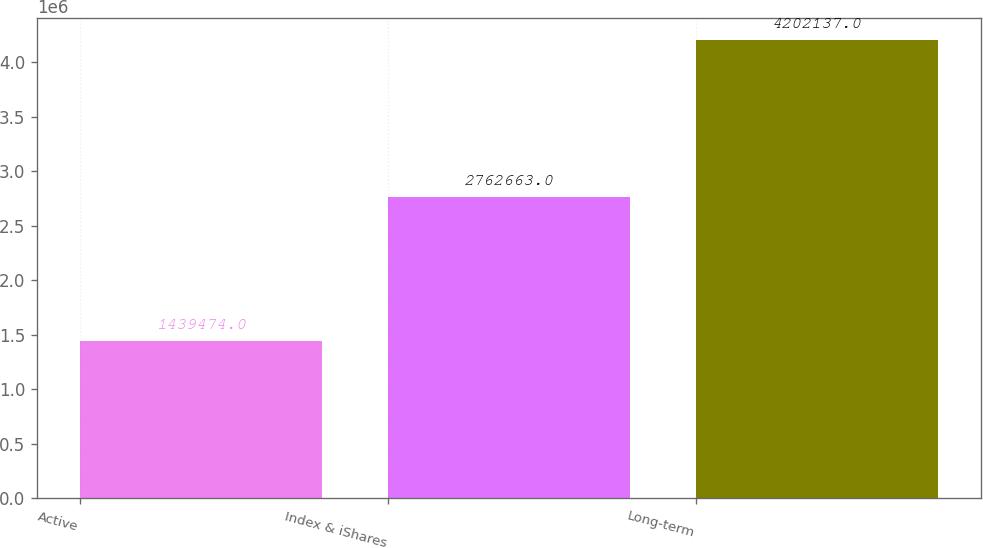<chart> <loc_0><loc_0><loc_500><loc_500><bar_chart><fcel>Active<fcel>Index & iShares<fcel>Long-term<nl><fcel>1.43947e+06<fcel>2.76266e+06<fcel>4.20214e+06<nl></chart> 